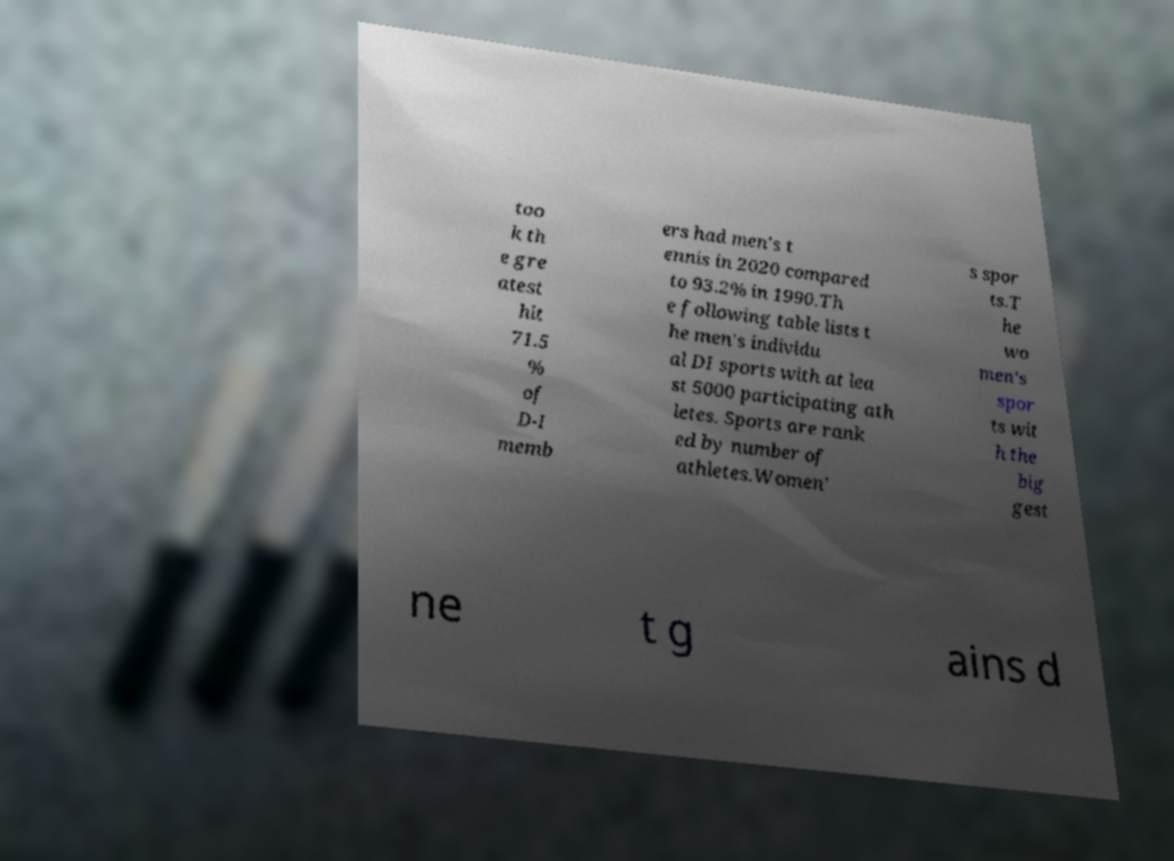Please read and relay the text visible in this image. What does it say? too k th e gre atest hit 71.5 % of D-I memb ers had men's t ennis in 2020 compared to 93.2% in 1990.Th e following table lists t he men's individu al DI sports with at lea st 5000 participating ath letes. Sports are rank ed by number of athletes.Women' s spor ts.T he wo men's spor ts wit h the big gest ne t g ains d 